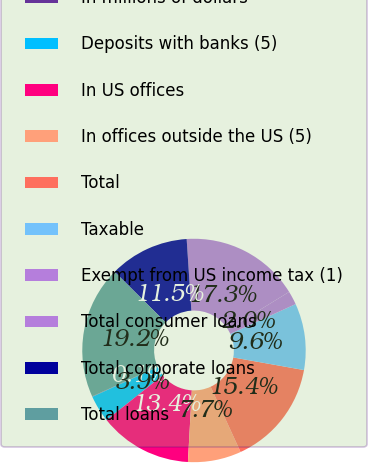Convert chart to OTSL. <chart><loc_0><loc_0><loc_500><loc_500><pie_chart><fcel>In millions of dollars<fcel>Deposits with banks (5)<fcel>In US offices<fcel>In offices outside the US (5)<fcel>Total<fcel>Taxable<fcel>Exempt from US income tax (1)<fcel>Total consumer loans<fcel>Total corporate loans<fcel>Total loans<nl><fcel>0.06%<fcel>3.89%<fcel>13.44%<fcel>7.71%<fcel>15.35%<fcel>9.62%<fcel>1.97%<fcel>17.26%<fcel>11.53%<fcel>19.17%<nl></chart> 